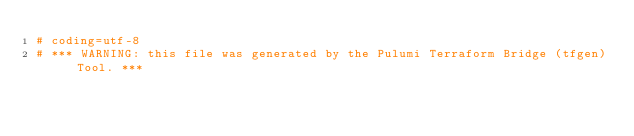Convert code to text. <code><loc_0><loc_0><loc_500><loc_500><_Python_># coding=utf-8
# *** WARNING: this file was generated by the Pulumi Terraform Bridge (tfgen) Tool. ***</code> 